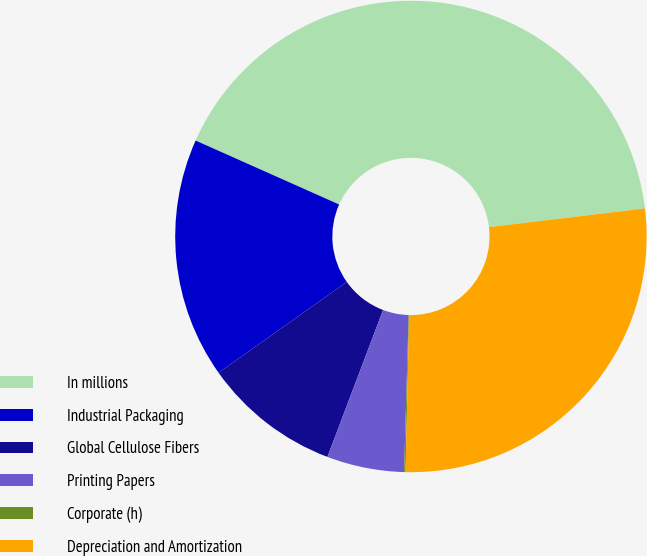Convert chart. <chart><loc_0><loc_0><loc_500><loc_500><pie_chart><fcel>In millions<fcel>Industrial Packaging<fcel>Global Cellulose Fibers<fcel>Printing Papers<fcel>Corporate (h)<fcel>Depreciation and Amortization<nl><fcel>41.43%<fcel>16.48%<fcel>9.43%<fcel>5.3%<fcel>0.1%<fcel>27.26%<nl></chart> 